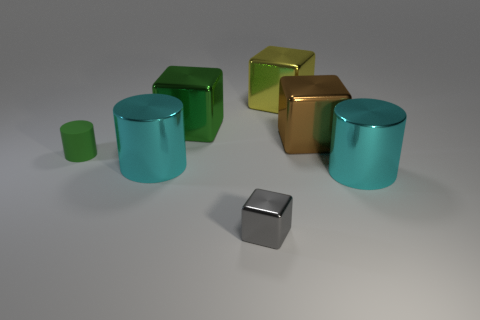How many other objects are the same size as the yellow object? Among the assortment of objects present, 4 share the same dimensions as the yellow object, accounting for variations in shape. 